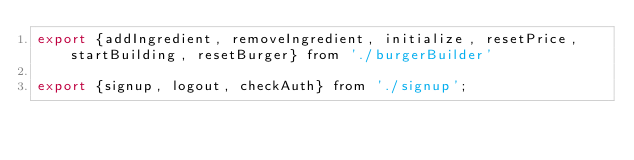<code> <loc_0><loc_0><loc_500><loc_500><_JavaScript_>export {addIngredient, removeIngredient, initialize, resetPrice, startBuilding, resetBurger} from './burgerBuilder'

export {signup, logout, checkAuth} from './signup';</code> 